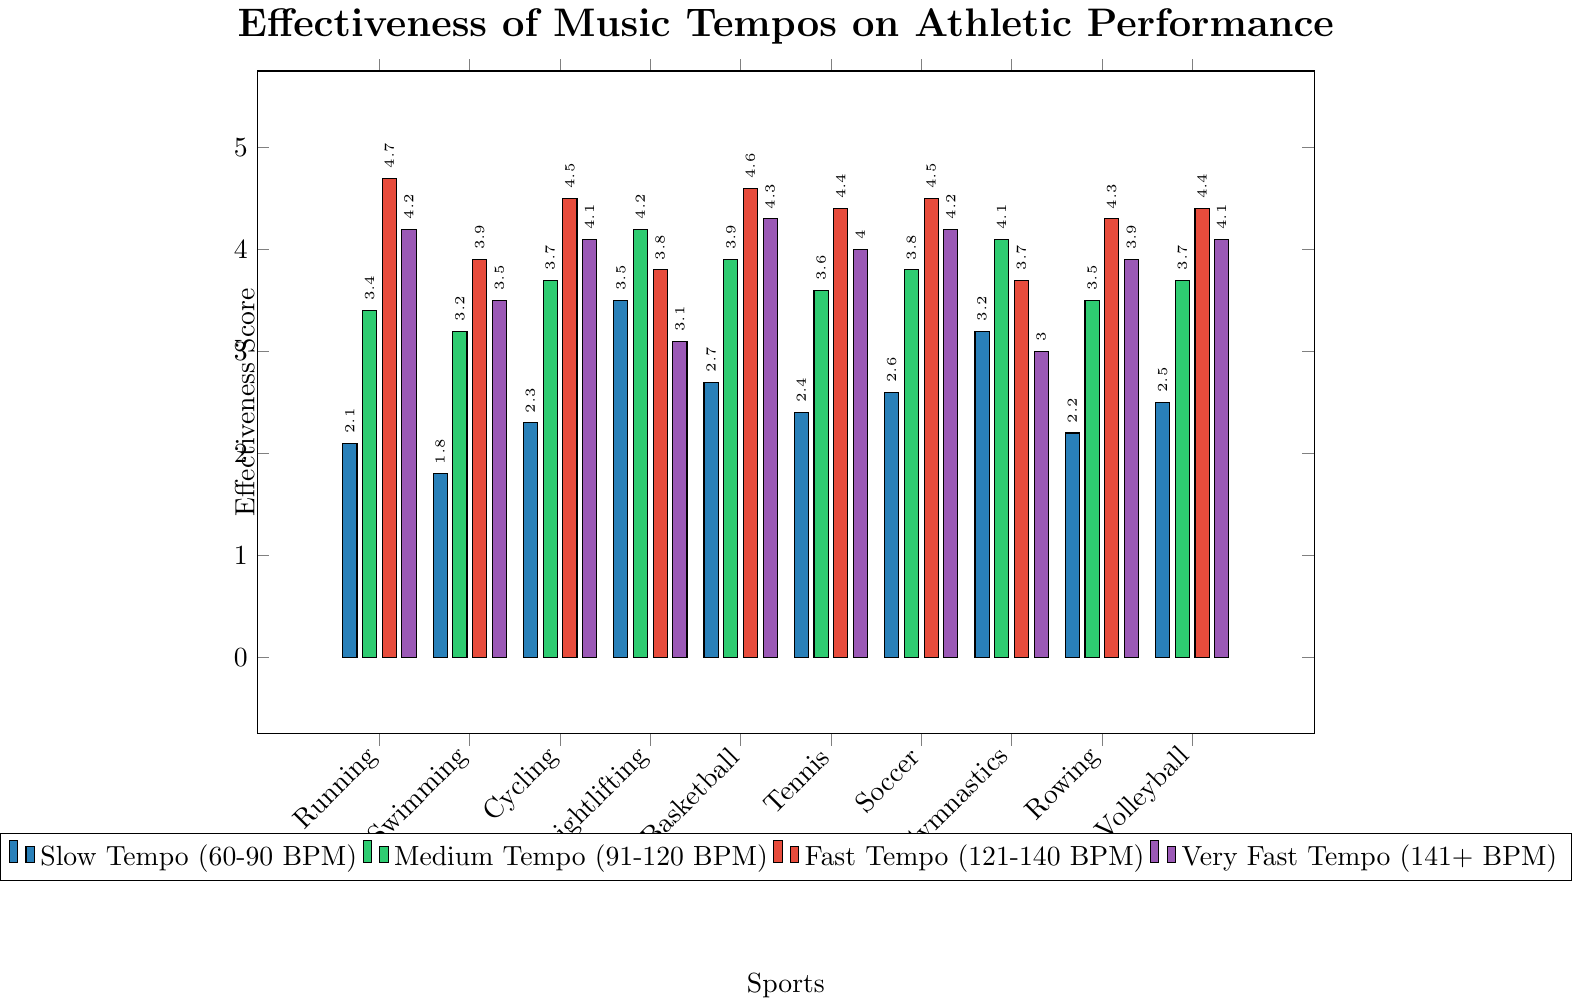What's the most effective tempo for running? Visual inspection shows that the Fast Tempo (121-140 BPM) bar is the highest for running. This indicates it is the most effective tempo.
Answer: Fast Tempo Which sport shows the highest effectiveness score for Medium Tempo (91-120 BPM)? By visually comparing the heights of the Medium Tempo bars across all sports, we see that Weightlifting has the highest bar.
Answer: Weightlifting What is the average effectiveness score for Gymnastics across all tempos? Sum the scores for Gymnastics (3.2 + 4.1 + 3.7 + 3.0) and divide by the number of tempos (4). The result is (3.2 + 4.1 + 3.7 + 3.0) / 4 = 14 / 4 = 3.5.
Answer: 3.5 Which sport has the lowest effectiveness score for Slow Tempo (60-90 BPM)? By examining the heights of the Slow Tempo bars, Swimming has the shortest bar, indicating the lowest effectiveness score.
Answer: Swimming How does the effectiveness score for Very Fast Tempo (141+ BPM) compare between Basketball and Volleyball? Compare the bar heights for Basketball and Volleyball under the Very Fast Tempo category. Basketball has a slightly higher bar than Volleyball.
Answer: Basketball > Volleyball What's the difference in effectiveness score between Fast Tempo (121-140 BPM) and Slow Tempo (60-90 BPM) for Cycling? Find and subtract the effectiveness scores for Cycling in these tempos: Fast Tempo (4.5) - Slow Tempo (2.3) = 2.2.
Answer: 2.2 Which sport has the smallest difference between the highest and lowest effectiveness scores across all tempos? Examine each sport's range by subtracting the smallest score from the largest score. For Swimming, it's 3.9 - 1.8 = 2.1. This is the smallest range among all sports.
Answer: Swimming How does the effectiveness score trend for Running change with increasing tempo? For Running, visually track the bar heights: Slow Tempo (2.1), Medium Tempo (3.4), Fast Tempo (4.7), Very Fast Tempo (4.2). It increases up to Fast Tempo and then slightly decreases.
Answer: Increases then decreases What is the total effectiveness score for Tennis across all tempos? Sum up the effectiveness scores for Tennis (2.4 + 3.6 + 4.4 + 4.0). The total is 2.4 + 3.6 + 4.4 + 4.0 = 14.4.
Answer: 14.4 For which sport does the Fast Tempo have its lowest effectiveness score? Examine all the Fast Tempo bars and find the lowest one. Weightlifting has the lowest Fast Tempo effectiveness score among all sports.
Answer: Weightlifting 